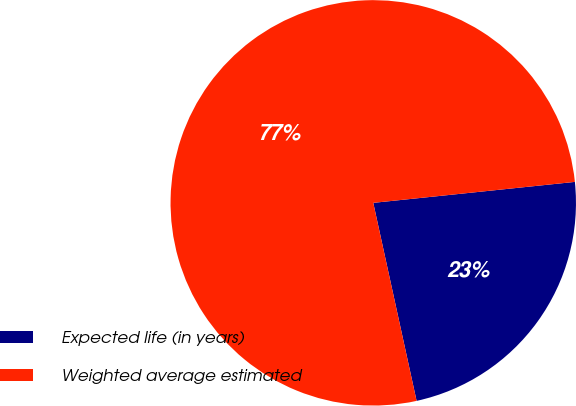Convert chart. <chart><loc_0><loc_0><loc_500><loc_500><pie_chart><fcel>Expected life (in years)<fcel>Weighted average estimated<nl><fcel>23.22%<fcel>76.78%<nl></chart> 